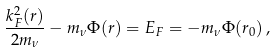Convert formula to latex. <formula><loc_0><loc_0><loc_500><loc_500>\frac { k _ { F } ^ { 2 } ( r ) } { 2 m _ { \nu } } - m _ { \nu } \Phi ( r ) = E _ { F } = - m _ { \nu } \Phi ( r _ { 0 } ) \, ,</formula> 